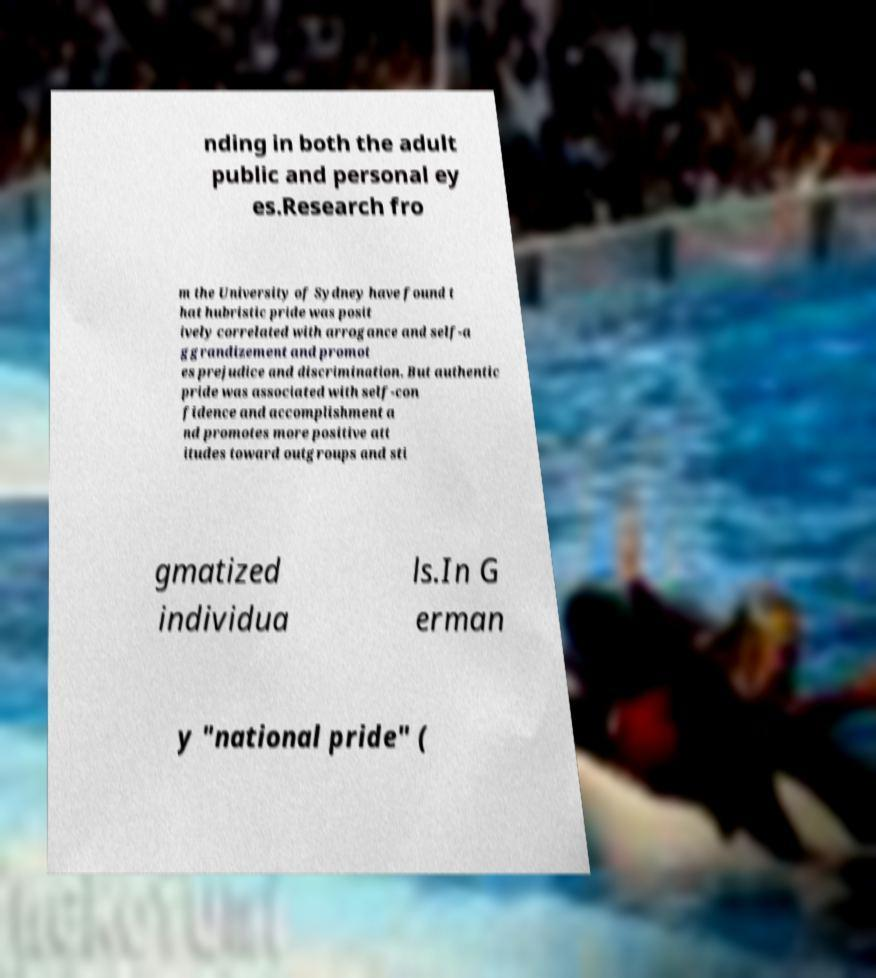Please identify and transcribe the text found in this image. nding in both the adult public and personal ey es.Research fro m the University of Sydney have found t hat hubristic pride was posit ively correlated with arrogance and self-a ggrandizement and promot es prejudice and discrimination. But authentic pride was associated with self-con fidence and accomplishment a nd promotes more positive att itudes toward outgroups and sti gmatized individua ls.In G erman y "national pride" ( 